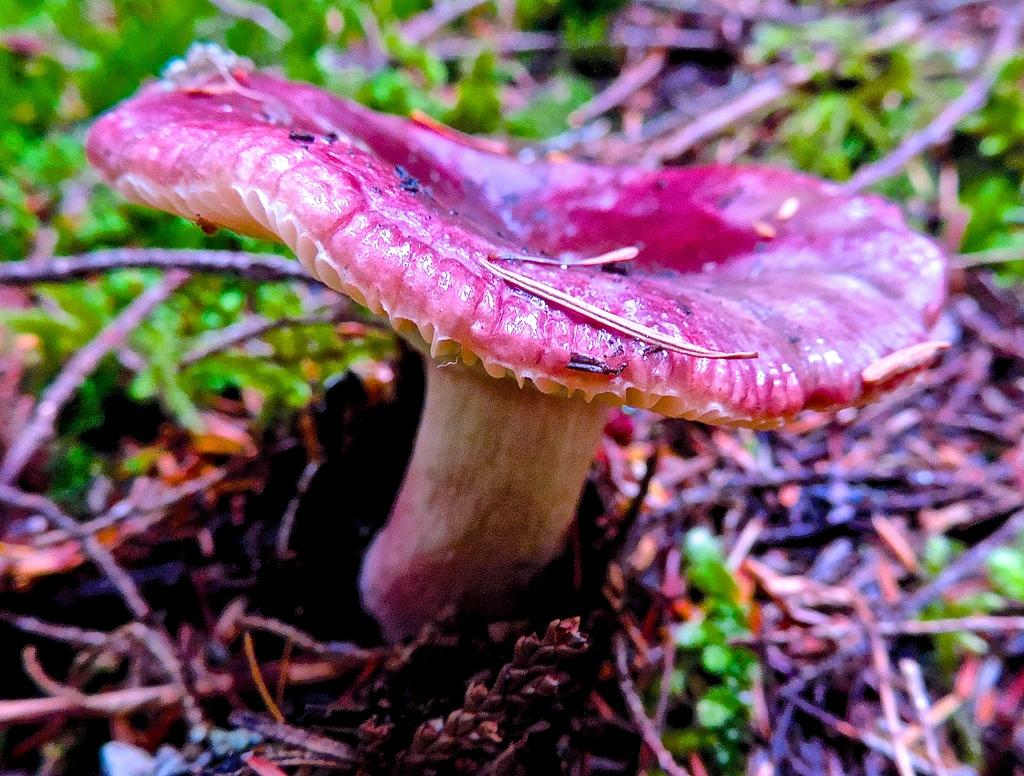What type of plant can be seen in the image? There is a mushroom in the image. What type of vegetation is present in the image? There is grass in the image. What objects can be found on the ground in the image? There are sticks on the ground in the image. How much power does the sink generate in the image? There is no sink present in the image, so it is not possible to determine how much power it generates. 